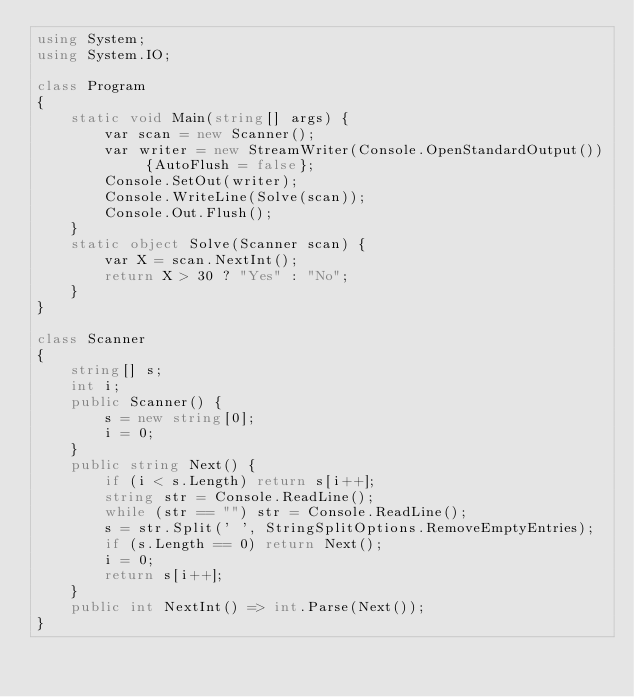<code> <loc_0><loc_0><loc_500><loc_500><_C#_>using System;
using System.IO;

class Program
{
    static void Main(string[] args) {
        var scan = new Scanner();
        var writer = new StreamWriter(Console.OpenStandardOutput()) {AutoFlush = false};
        Console.SetOut(writer);
        Console.WriteLine(Solve(scan));
        Console.Out.Flush();
    }
    static object Solve(Scanner scan) {
        var X = scan.NextInt();
        return X > 30 ? "Yes" : "No";
    }
}

class Scanner
{
    string[] s;
    int i;
    public Scanner() {
        s = new string[0];
        i = 0;
    }
    public string Next() {
        if (i < s.Length) return s[i++];
        string str = Console.ReadLine();
        while (str == "") str = Console.ReadLine();
        s = str.Split(' ', StringSplitOptions.RemoveEmptyEntries);
        if (s.Length == 0) return Next();
        i = 0;
        return s[i++];
    }
    public int NextInt() => int.Parse(Next());
}</code> 